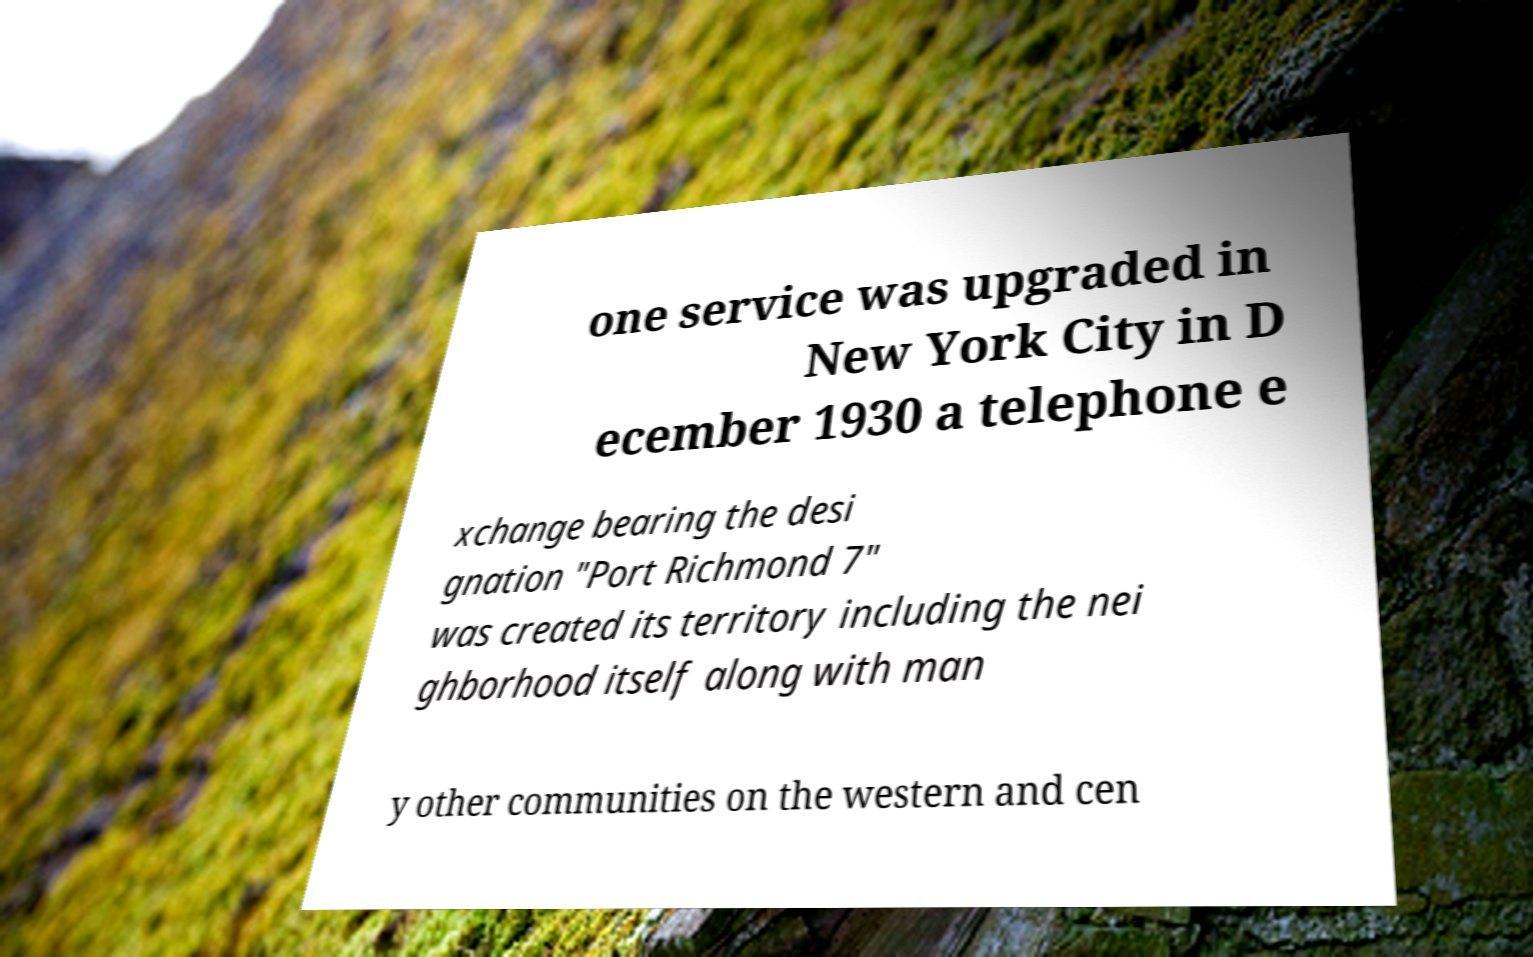There's text embedded in this image that I need extracted. Can you transcribe it verbatim? one service was upgraded in New York City in D ecember 1930 a telephone e xchange bearing the desi gnation "Port Richmond 7" was created its territory including the nei ghborhood itself along with man y other communities on the western and cen 